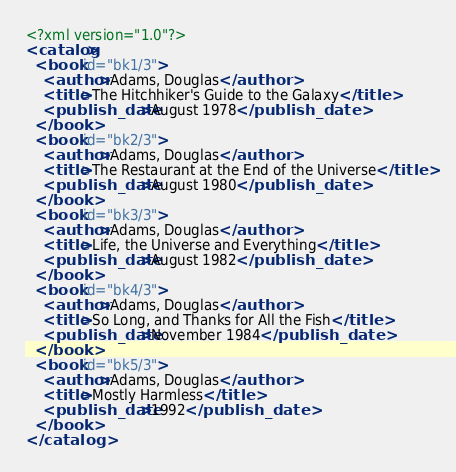Convert code to text. <code><loc_0><loc_0><loc_500><loc_500><_XML_><?xml version="1.0"?>
<catalog>
  <book id="bk1/3">
    <author>Adams, Douglas</author>
    <title>The Hitchhiker's Guide to the Galaxy</title>
    <publish_date>August 1978</publish_date>
  </book>
  <book id="bk2/3">
    <author>Adams, Douglas</author>
    <title>The Restaurant at the End of the Universe</title>
    <publish_date>August 1980</publish_date>
  </book>
  <book id="bk3/3">
    <author>Adams, Douglas</author>
    <title>Life, the Universe and Everything</title>
    <publish_date>August 1982</publish_date>
  </book>
  <book id="bk4/3">
    <author>Adams, Douglas</author>
    <title>So Long, and Thanks for All the Fish</title>
    <publish_date>November 1984</publish_date>
  </book>
  <book id="bk5/3">
    <author>Adams, Douglas</author>
    <title>Mostly Harmless</title>
    <publish_date>1992</publish_date>
  </book>
</catalog>
</code> 